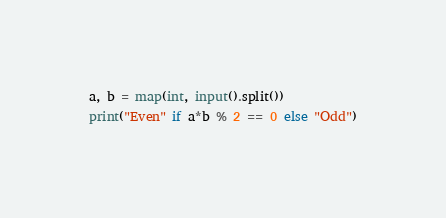Convert code to text. <code><loc_0><loc_0><loc_500><loc_500><_Python_>a, b = map(int, input().split())
print("Even" if a*b % 2 == 0 else "Odd")</code> 